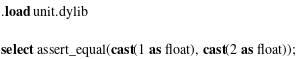<code> <loc_0><loc_0><loc_500><loc_500><_SQL_>.load unit.dylib

select assert_equal(cast(1 as float), cast(2 as float));</code> 